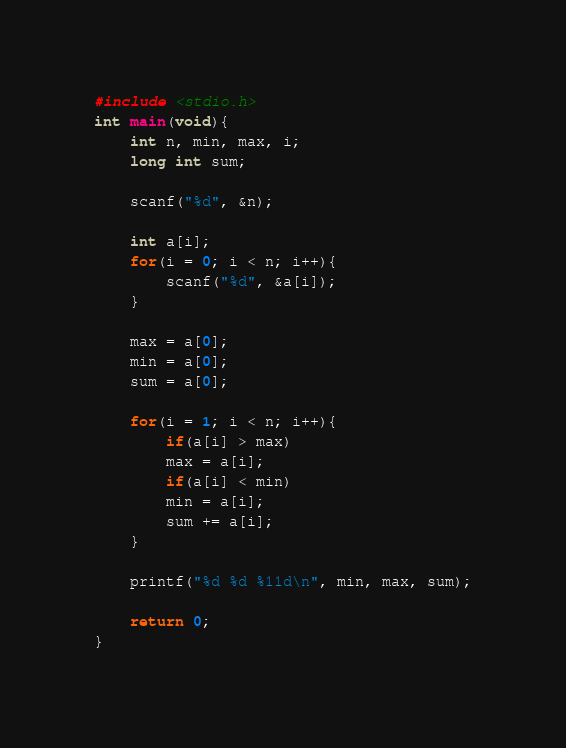<code> <loc_0><loc_0><loc_500><loc_500><_C_>#include <stdio.h>
int main(void){
    int n, min, max, i;
    long int sum;
    
    scanf("%d", &n);
    
    int a[i];
    for(i = 0; i < n; i++){
        scanf("%d", &a[i]);
    }
    
    max = a[0];
    min = a[0];
    sum = a[0];
    
    for(i = 1; i < n; i++){
        if(a[i] > max)
        max = a[i];
        if(a[i] < min)
        min = a[i];
        sum += a[i];
    }
    
    printf("%d %d %11d\n", min, max, sum);
    
    return 0;
}

</code> 